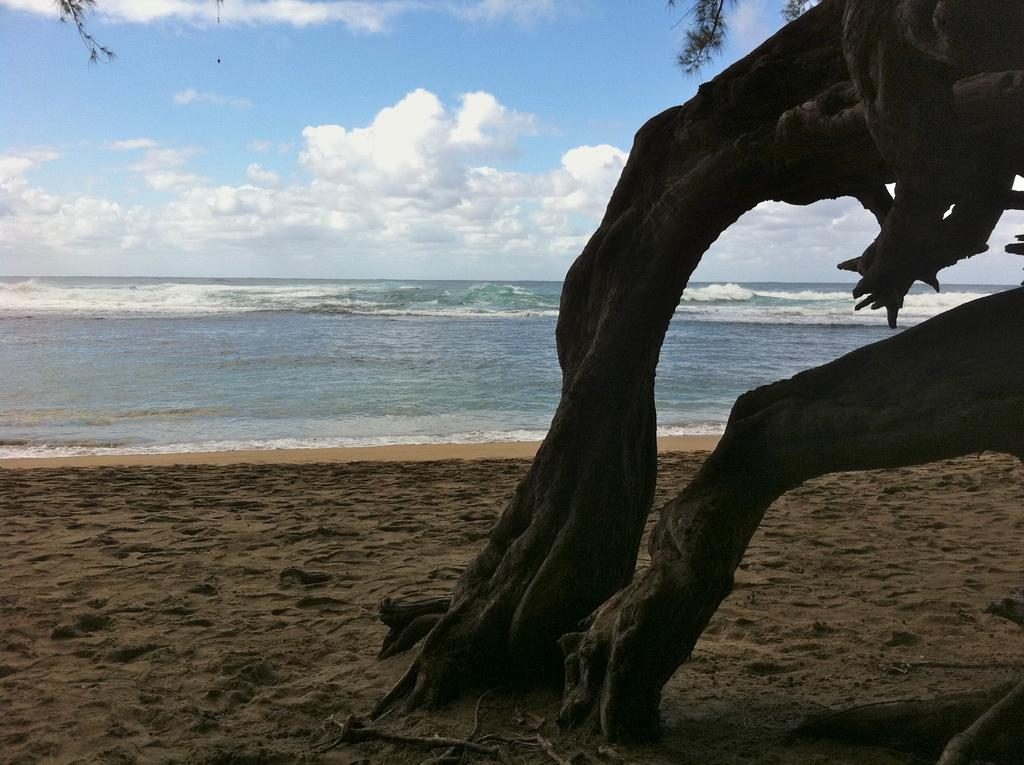What type of natural environment is depicted in the image? The image features an ocean and a beach. Can you describe any landmarks or objects on the beach? There is a tree on the right side of the image. What can be seen in the background of the image? The sky is visible in the background of the image. What type of expansion is occurring on the beach in the image? There is no expansion occurring on the beach in the image. What liquid can be seen flowing on the beach in the image? There is no liquid flowing on the beach in the image. 